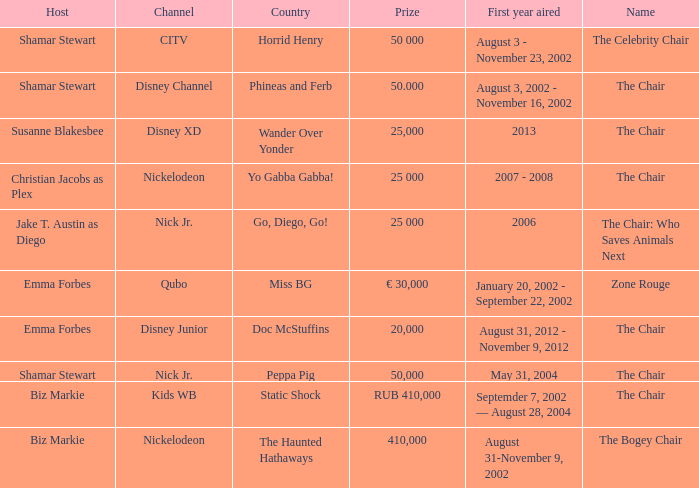What was the first year that had a prize of 50,000? May 31, 2004. 